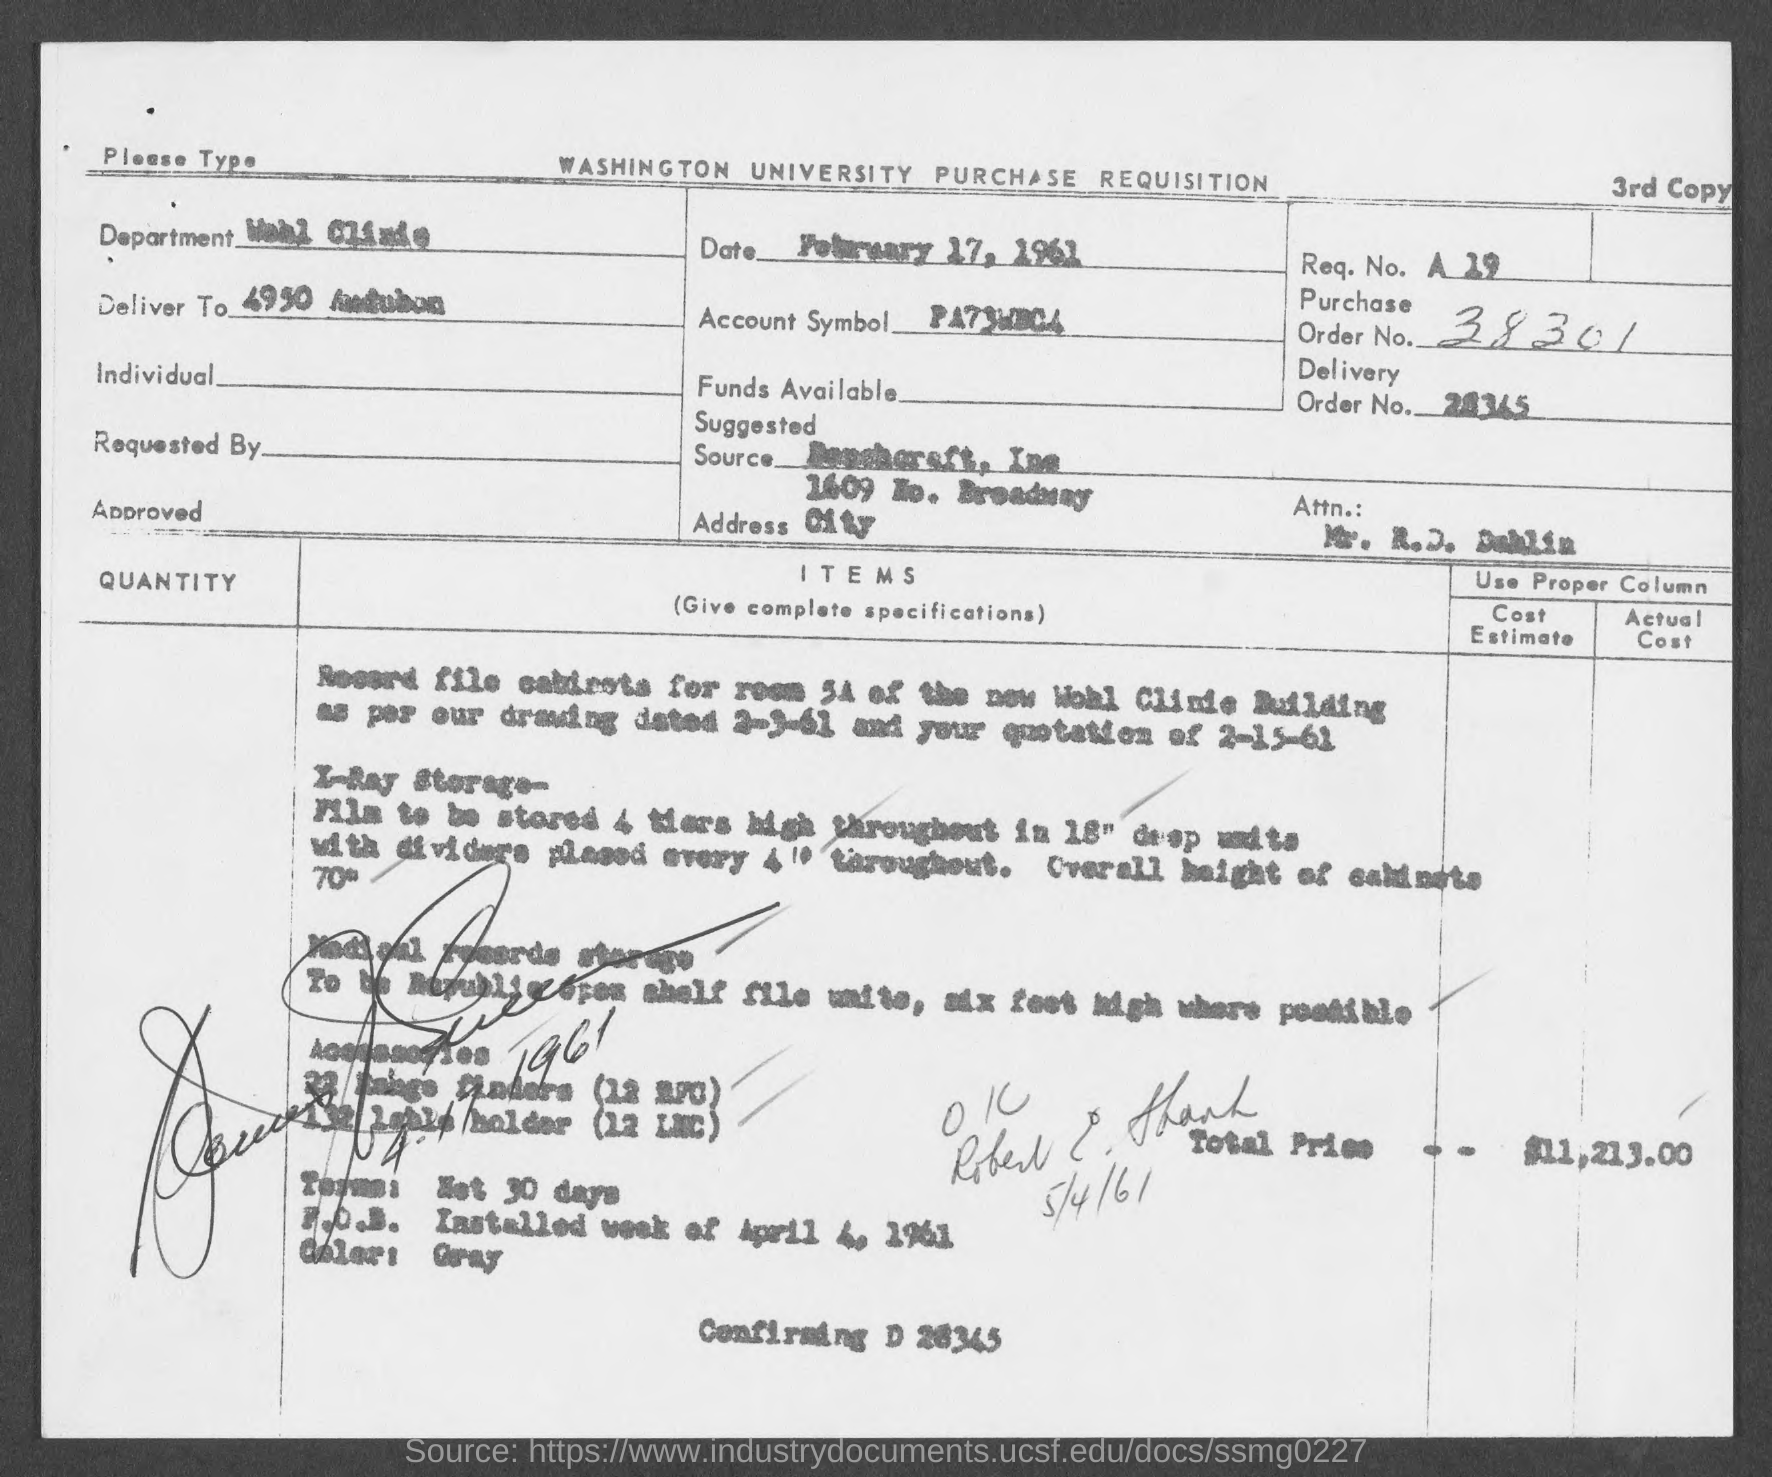What is the name of the department mentioned in the given form ?
Make the answer very short. Wohl clinic. What is the date mentioned in the given page ?
Keep it short and to the point. February 17, 1961. What is the purchase order no. mentioned in the given page ?
Your answer should be compact. 38301. What is the total price mentioned in the given form ?
Provide a succinct answer. $ 11,213.00. 